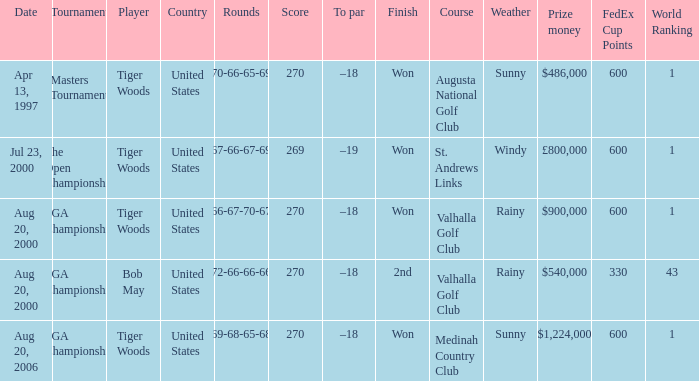What is the worst (highest) score? 270.0. 